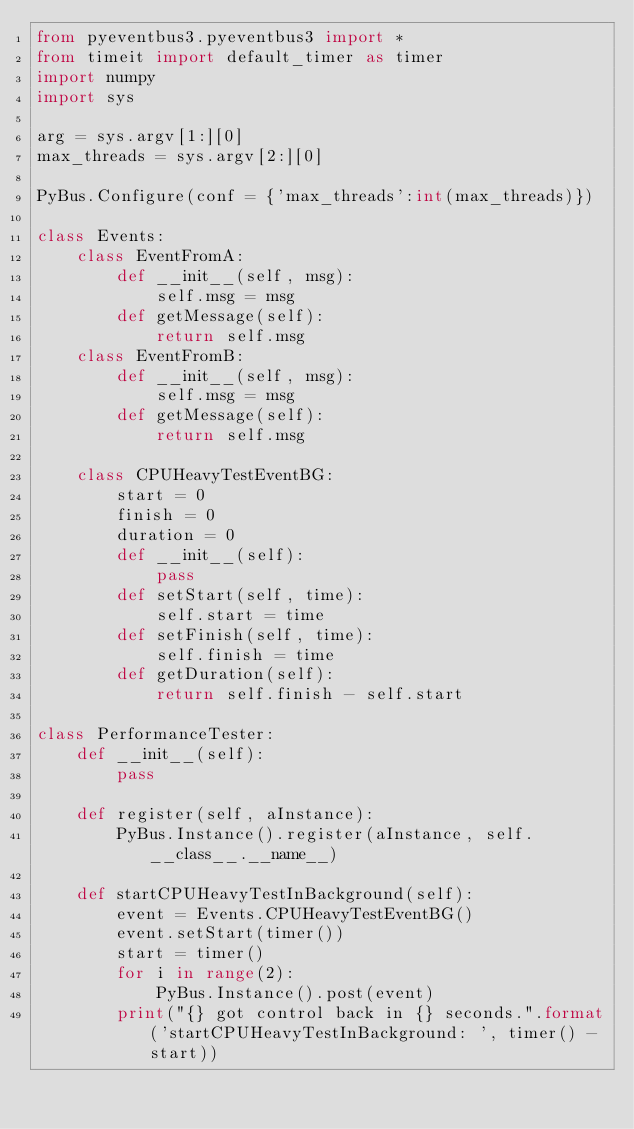Convert code to text. <code><loc_0><loc_0><loc_500><loc_500><_Python_>from pyeventbus3.pyeventbus3 import *
from timeit import default_timer as timer
import numpy
import sys

arg = sys.argv[1:][0]
max_threads = sys.argv[2:][0]

PyBus.Configure(conf = {'max_threads':int(max_threads)})

class Events:
    class EventFromA:
        def __init__(self, msg):
            self.msg = msg
        def getMessage(self):
            return self.msg
    class EventFromB:
        def __init__(self, msg):
            self.msg = msg
        def getMessage(self):
            return self.msg

    class CPUHeavyTestEventBG:
        start = 0
        finish = 0
        duration = 0
        def __init__(self):
            pass
        def setStart(self, time):
            self.start = time
        def setFinish(self, time):
            self.finish = time
        def getDuration(self):
            return self.finish - self.start

class PerformanceTester:
    def __init__(self):
        pass

    def register(self, aInstance):
        PyBus.Instance().register(aInstance, self.__class__.__name__)

    def startCPUHeavyTestInBackground(self):
        event = Events.CPUHeavyTestEventBG()
        event.setStart(timer())
        start = timer()
        for i in range(2):
            PyBus.Instance().post(event)
        print("{} got control back in {} seconds.".format('startCPUHeavyTestInBackground: ', timer() - start))

</code> 